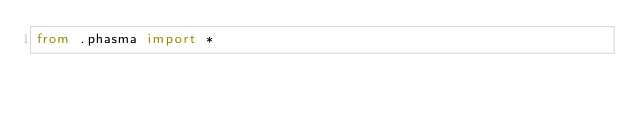Convert code to text. <code><loc_0><loc_0><loc_500><loc_500><_Python_>from .phasma import *</code> 